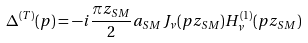<formula> <loc_0><loc_0><loc_500><loc_500>\Delta ^ { ( T ) } ( p ) = - i \frac { \pi z _ { S M } } { 2 } a _ { S M } J _ { \nu } ( p z _ { S M } ) H ^ { ( 1 ) } _ { \nu } ( p z _ { S M } )</formula> 